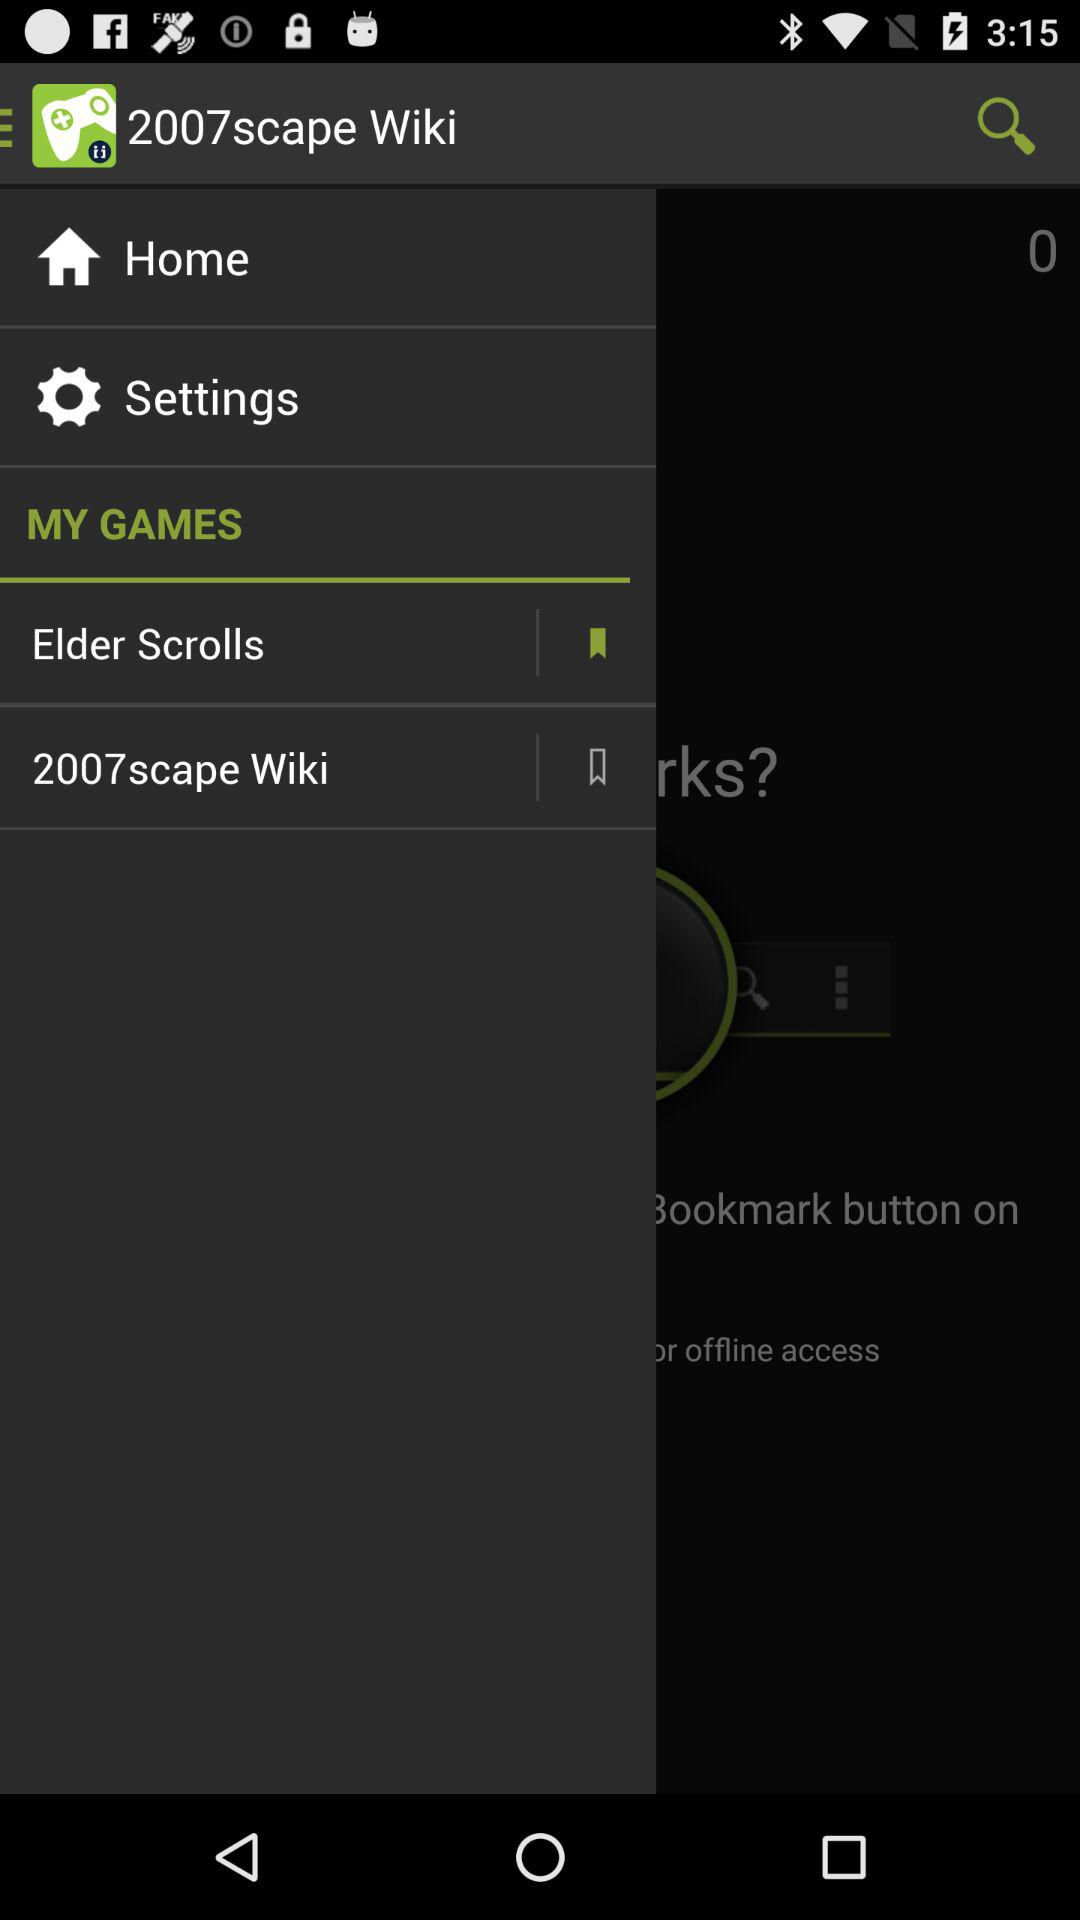What is the application name? The application name is "2007scape Wiki". 